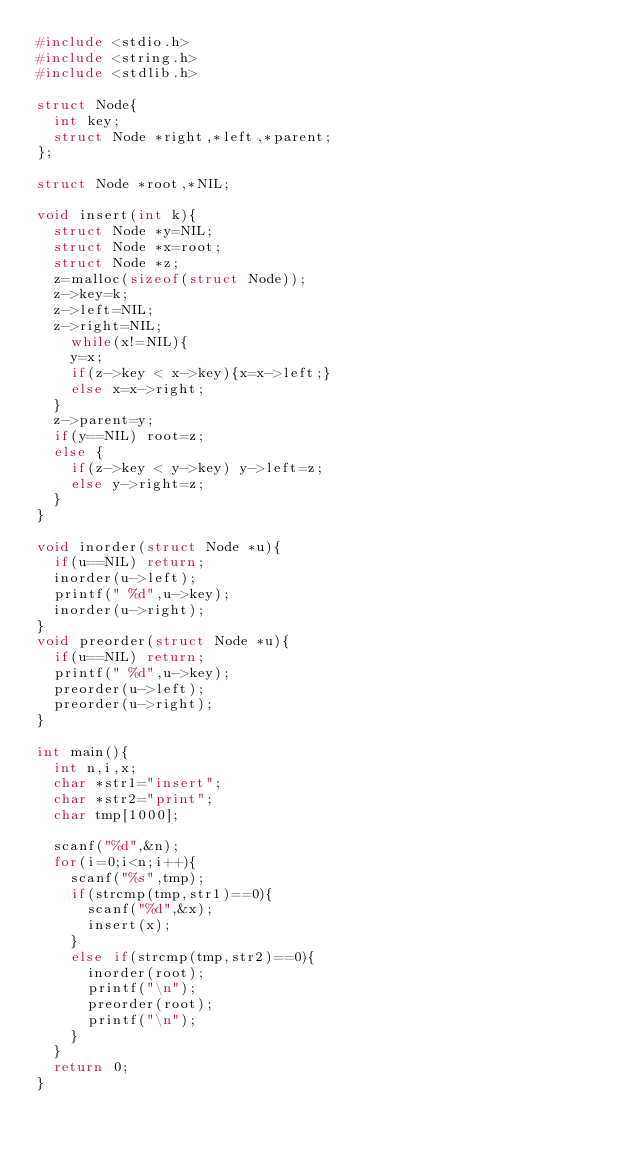Convert code to text. <code><loc_0><loc_0><loc_500><loc_500><_C_>#include <stdio.h>
#include <string.h>
#include <stdlib.h>

struct Node{
  int key;
  struct Node *right,*left,*parent;
};

struct Node *root,*NIL;

void insert(int k){
  struct Node *y=NIL;
  struct Node *x=root;
  struct Node *z;
  z=malloc(sizeof(struct Node));
  z->key=k;
  z->left=NIL;
  z->right=NIL;
    while(x!=NIL){
    y=x;
    if(z->key < x->key){x=x->left;}
    else x=x->right;
  }
  z->parent=y;
  if(y==NIL) root=z;
  else {
    if(z->key < y->key) y->left=z;
    else y->right=z;
  }
}

void inorder(struct Node *u){
  if(u==NIL) return;
  inorder(u->left);
  printf(" %d",u->key);
  inorder(u->right);
}
void preorder(struct Node *u){
  if(u==NIL) return;
  printf(" %d",u->key);
  preorder(u->left);
  preorder(u->right);
}

int main(){
  int n,i,x;
  char *str1="insert";
  char *str2="print";
  char tmp[1000];

  scanf("%d",&n);
  for(i=0;i<n;i++){
    scanf("%s",tmp);
    if(strcmp(tmp,str1)==0){
      scanf("%d",&x);
      insert(x);
    }
    else if(strcmp(tmp,str2)==0){
      inorder(root);
      printf("\n");
      preorder(root);
      printf("\n");
    }
  }
  return 0;
}

</code> 